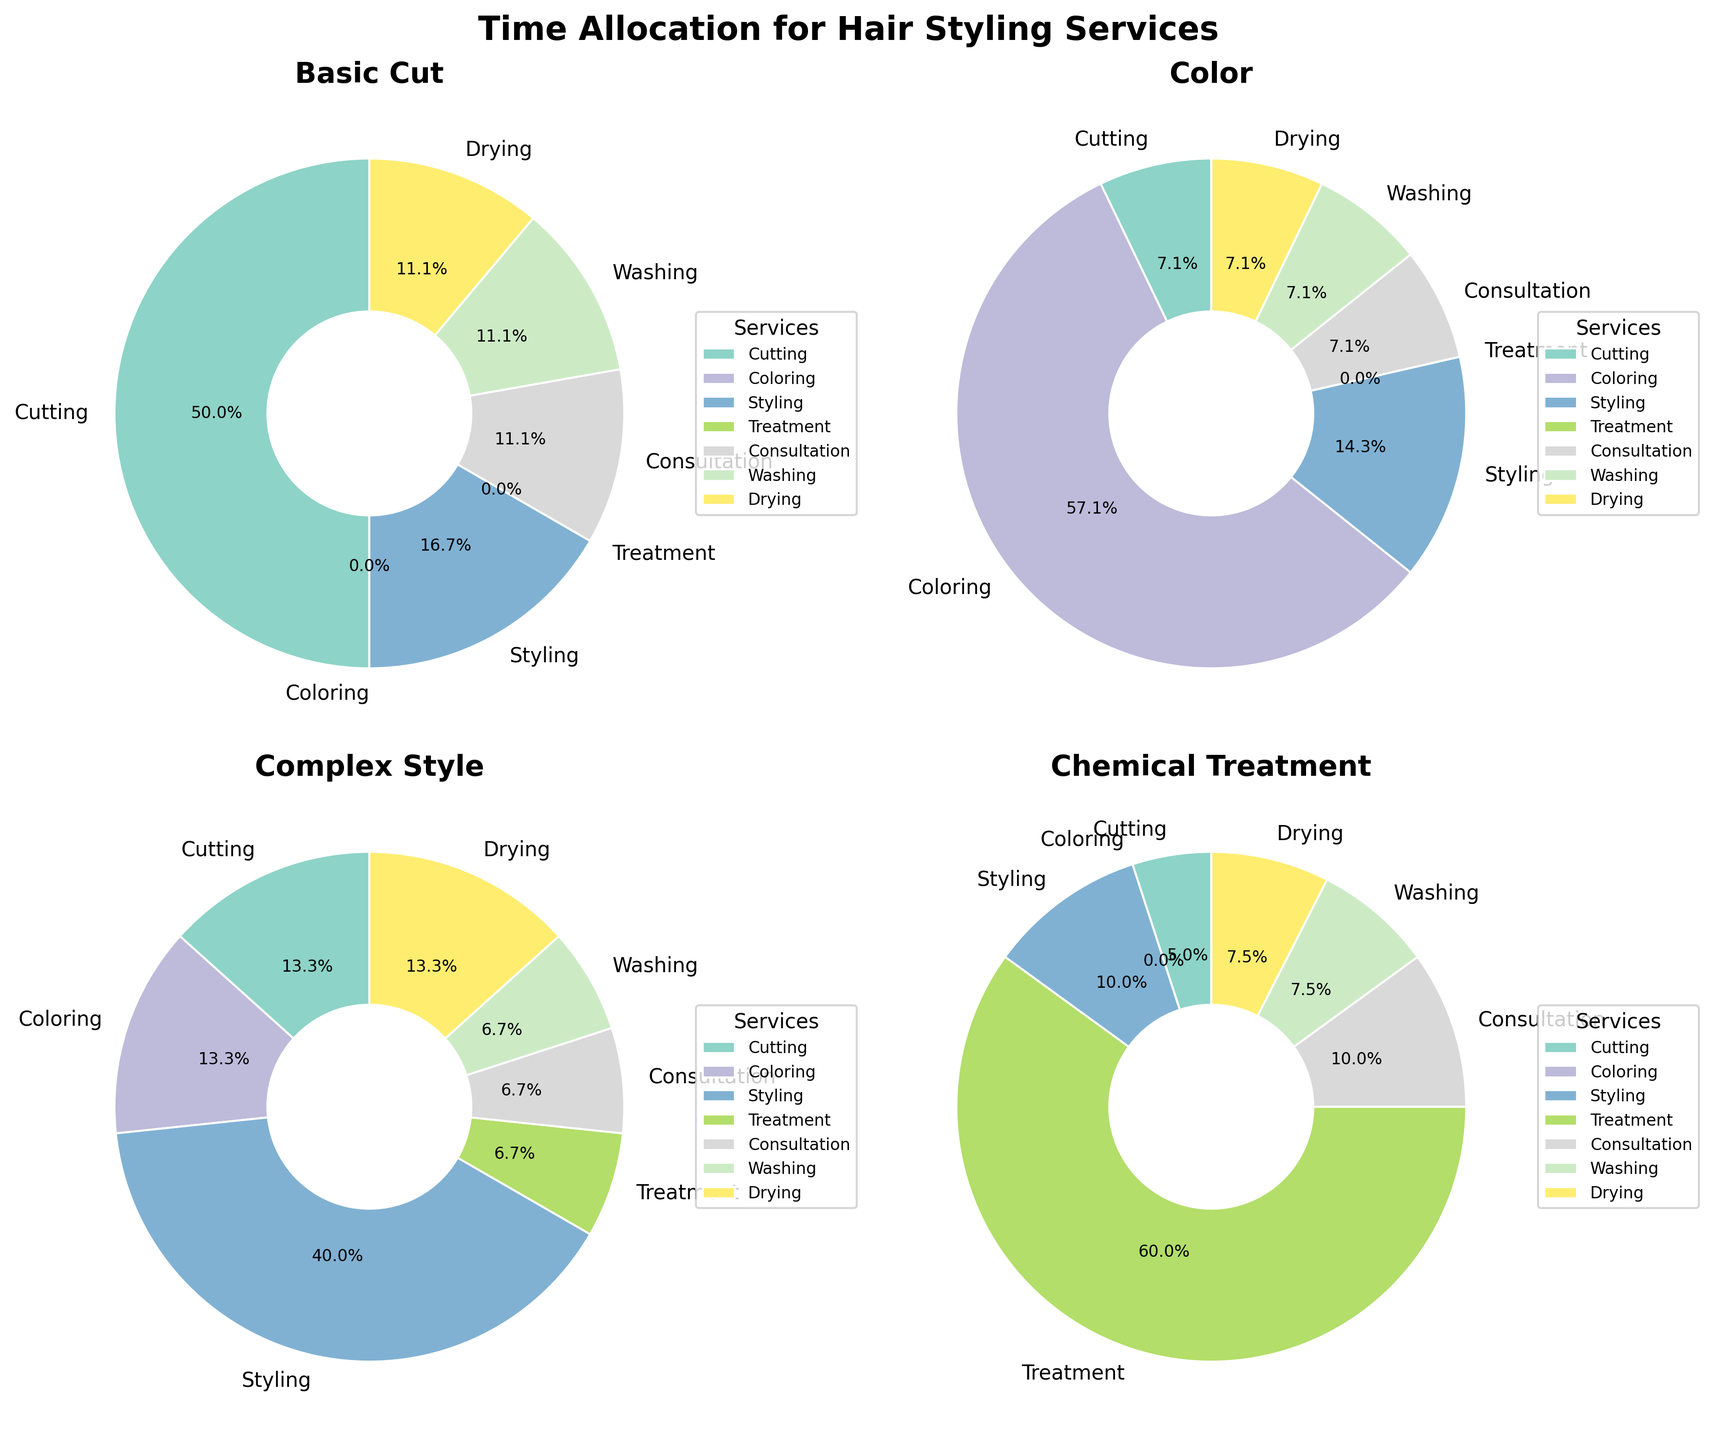What is the title of the figure? The title of the figure is prominently displayed at the top center of the plot. It states the overall theme of the subplot of pie charts.
Answer: Time Allocation for Hair Styling Services Which hair service has the longest allocated time for "Coloring"? To answer this, look at the "Coloring" pie chart and identify the slice with the largest size.
Answer: Coloring What percentage of time is spent on "Consultation" for "Chemical Treatment"? Check the "Chemical Treatment" pie chart and find the slice labeled "Consultation". The percentage is shown within the slice.
Answer: 11.1% What is the combined percentage of time spent on "Washing" and "Drying" for "Basic Cut"? Find the "Basic Cut" pie chart and sum the percentages of the "Washing" and "Drying" slices.
Answer: 20% Which service has the smallest time allocation for "Complex Style"? Examine the "Complex Style" pie chart and identify the smallest slice.
Answer: Treatment Compare the time allocated to "Styling" in "Basic Cut" and "Complex Style". Which is greater? Check the pie charts for "Basic Cut" and "Complex Style" and compare the sizes of the "Styling" slices.
Answer: Complex Style How does the percentage of "Cutting" time in "Chemical Treatment" compare to "Color"? Compare the sizes of the "Cutting" slices in the "Chemical Treatment" and "Color" pie charts to see which is larger.
Answer: Chemical Treatment is smaller than Color What is the total percentage of time allocated to "Consultation" across all hair services ("Basic Cut", "Color", "Complex Style", "Chemical Treatment")? Sum the percentages of "Consultation" slices from all four pie charts.
Answer: 15% + 11.1% + 7.5% + 8.3% = 41.9% Which hair service has the most evenly distributed time allocation among all categories? Identify the pie chart where the slices appear most similar in size.
Answer: Complex Style 